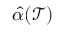<formula> <loc_0><loc_0><loc_500><loc_500>\hat { \alpha } ( \mathcal { T } )</formula> 